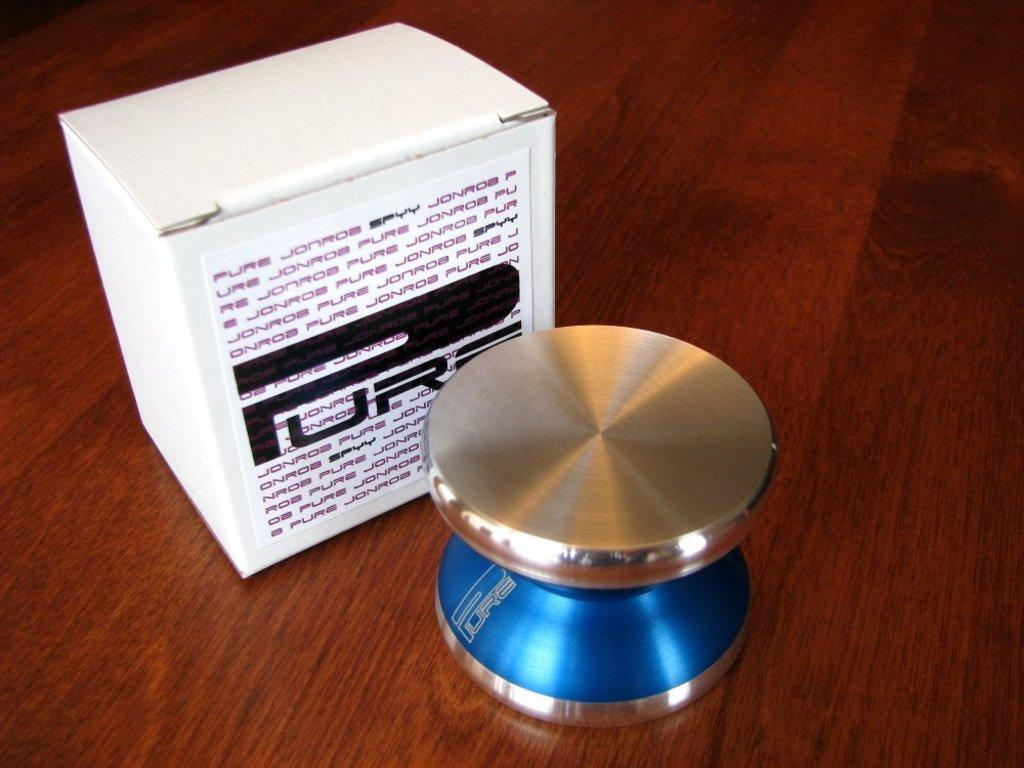<image>
Give a short and clear explanation of the subsequent image. a box saying PURE JONROE SPYY and the round metal object says PURE also that goes into the box. 